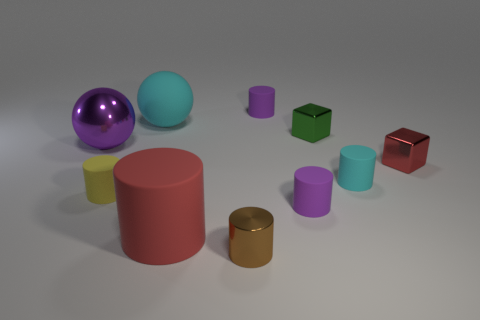Is there anything else that is the same color as the small shiny cylinder?
Ensure brevity in your answer.  No. Does the big matte cylinder have the same color as the tiny metal cylinder?
Ensure brevity in your answer.  No. What number of objects are tiny purple cylinders that are in front of the shiny sphere or purple metallic objects?
Your answer should be compact. 2. The other cyan cylinder that is the same material as the large cylinder is what size?
Offer a very short reply. Small. Is the number of big red matte cylinders to the right of the small cyan cylinder greater than the number of big purple spheres?
Offer a terse response. No. Is the shape of the small yellow rubber object the same as the small purple thing in front of the small green object?
Provide a succinct answer. Yes. What number of small things are purple balls or red rubber things?
Keep it short and to the point. 0. There is a matte object that is the same color as the large rubber ball; what size is it?
Keep it short and to the point. Small. There is a tiny matte cylinder that is left of the small metal object that is in front of the small red shiny block; what color is it?
Ensure brevity in your answer.  Yellow. Do the tiny brown thing and the tiny purple cylinder that is behind the tiny green metallic thing have the same material?
Offer a terse response. No. 